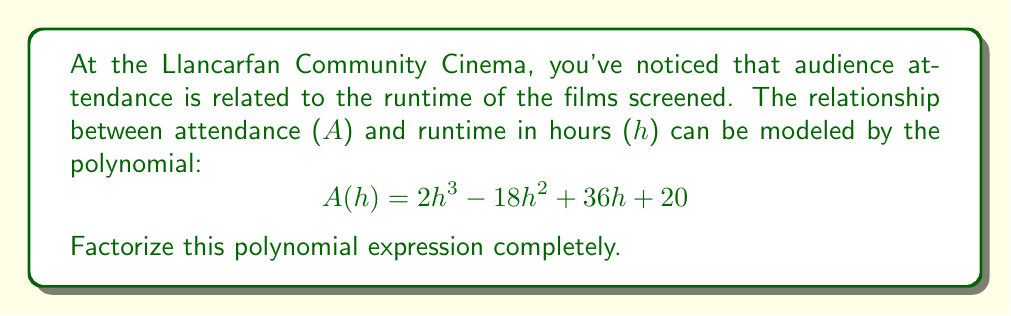Help me with this question. Let's approach this step-by-step:

1) First, we can check if there are any common factors. In this case, there are no common factors for all terms.

2) Next, we can try to identify if this is a perfect cube polynomial (since the highest degree is 3). However, it doesn't fit the pattern of $a^3 + 3a^2b + 3ab^2 + b^3$, so it's not a perfect cube.

3) Let's try to find factors using the rational root theorem. The possible rational roots are the factors of the constant term (20): ±1, ±2, ±4, ±5, ±10, ±20.

4) Testing these values, we find that h = 1 is a root. So (h - 1) is a factor.

5) We can use polynomial long division to divide $2h^3 - 18h^2 + 36h + 20$ by (h - 1):

   $$ 2h^3 - 18h^2 + 36h + 20 = (h - 1)(2h^2 - 16h + 20) $$

6) Now we need to factor the quadratic expression $2h^2 - 16h + 20$.

7) The quadratic formula can be used, but let's try factoring by grouping first:
   $2h^2 - 16h + 20 = 2(h^2 - 8h + 10) = 2(h - 2)(h - 5)$

8) Therefore, the complete factorization is:

   $$ A(h) = 2h^3 - 18h^2 + 36h + 20 = 2(h - 1)(h - 2)(h - 5) $$
Answer: $2(h - 1)(h - 2)(h - 5)$ 